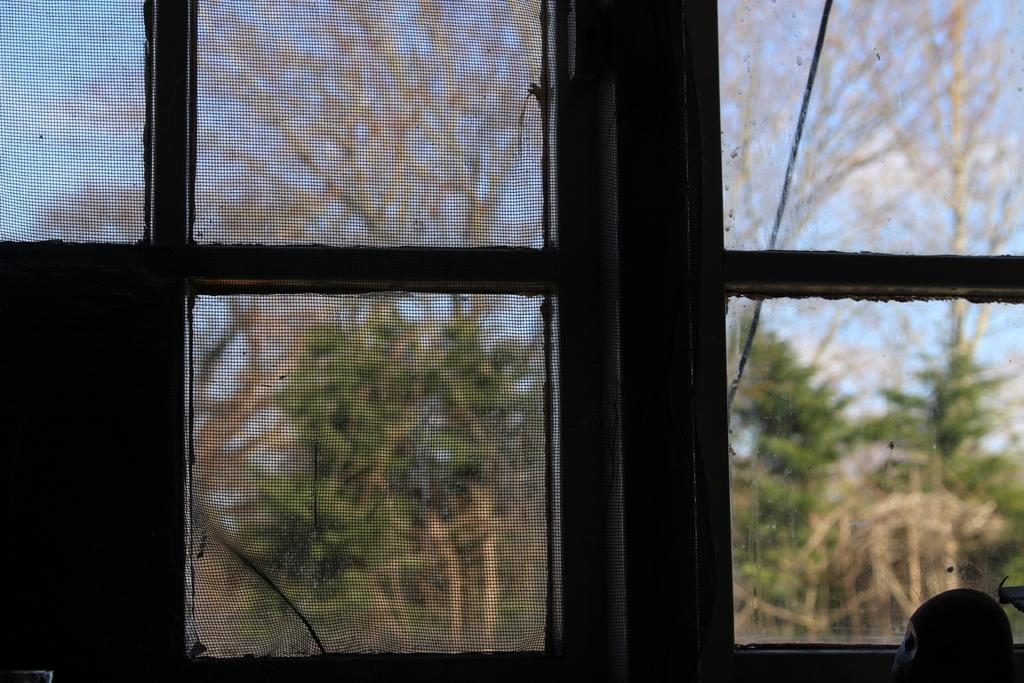What type of structure is present in the image? There is a glass window in the image. What can be seen through the glass window? Trees are visible through the glass window. What is the color of the sky in the image? The sky is blue in the image. What type of fruit is hanging from the paper in the image? There is no fruit or paper present in the image. 